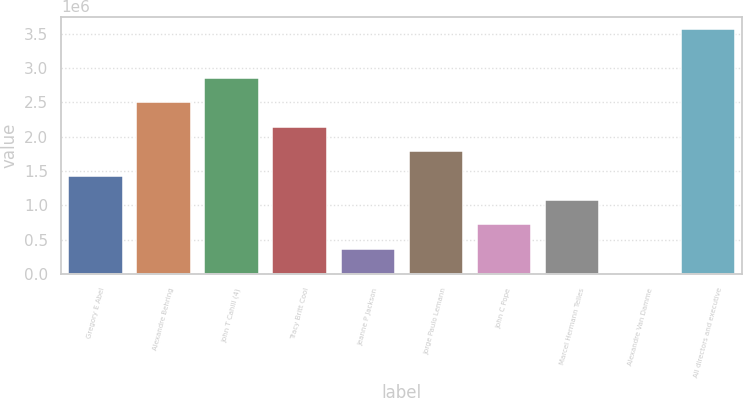<chart> <loc_0><loc_0><loc_500><loc_500><bar_chart><fcel>Gregory E Abel<fcel>Alexandre Behring<fcel>John T Cahill (4)<fcel>Tracy Britt Cool<fcel>Jeanne P Jackson<fcel>Jorge Paulo Lemann<fcel>John C Pope<fcel>Marcel Hermann Telles<fcel>Alexandre Van Damme<fcel>All directors and executive<nl><fcel>1.43413e+06<fcel>2.50352e+06<fcel>2.85999e+06<fcel>2.14706e+06<fcel>364734<fcel>1.79059e+06<fcel>721199<fcel>1.07766e+06<fcel>8269<fcel>3.57292e+06<nl></chart> 